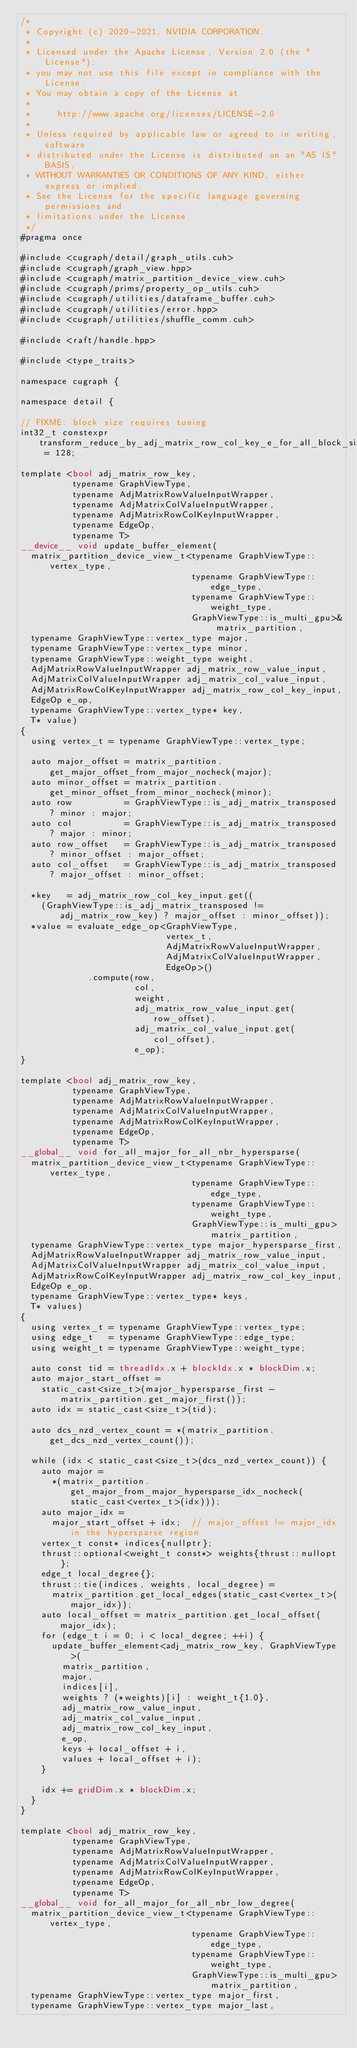Convert code to text. <code><loc_0><loc_0><loc_500><loc_500><_Cuda_>/*
 * Copyright (c) 2020-2021, NVIDIA CORPORATION.
 *
 * Licensed under the Apache License, Version 2.0 (the "License");
 * you may not use this file except in compliance with the License.
 * You may obtain a copy of the License at
 *
 *     http://www.apache.org/licenses/LICENSE-2.0
 *
 * Unless required by applicable law or agreed to in writing, software
 * distributed under the License is distributed on an "AS IS" BASIS,
 * WITHOUT WARRANTIES OR CONDITIONS OF ANY KIND, either express or implied.
 * See the License for the specific language governing permissions and
 * limitations under the License.
 */
#pragma once

#include <cugraph/detail/graph_utils.cuh>
#include <cugraph/graph_view.hpp>
#include <cugraph/matrix_partition_device_view.cuh>
#include <cugraph/prims/property_op_utils.cuh>
#include <cugraph/utilities/dataframe_buffer.cuh>
#include <cugraph/utilities/error.hpp>
#include <cugraph/utilities/shuffle_comm.cuh>

#include <raft/handle.hpp>

#include <type_traits>

namespace cugraph {

namespace detail {

// FIXME: block size requires tuning
int32_t constexpr transform_reduce_by_adj_matrix_row_col_key_e_for_all_block_size = 128;

template <bool adj_matrix_row_key,
          typename GraphViewType,
          typename AdjMatrixRowValueInputWrapper,
          typename AdjMatrixColValueInputWrapper,
          typename AdjMatrixRowColKeyInputWrapper,
          typename EdgeOp,
          typename T>
__device__ void update_buffer_element(
  matrix_partition_device_view_t<typename GraphViewType::vertex_type,
                                 typename GraphViewType::edge_type,
                                 typename GraphViewType::weight_type,
                                 GraphViewType::is_multi_gpu>& matrix_partition,
  typename GraphViewType::vertex_type major,
  typename GraphViewType::vertex_type minor,
  typename GraphViewType::weight_type weight,
  AdjMatrixRowValueInputWrapper adj_matrix_row_value_input,
  AdjMatrixColValueInputWrapper adj_matrix_col_value_input,
  AdjMatrixRowColKeyInputWrapper adj_matrix_row_col_key_input,
  EdgeOp e_op,
  typename GraphViewType::vertex_type* key,
  T* value)
{
  using vertex_t = typename GraphViewType::vertex_type;

  auto major_offset = matrix_partition.get_major_offset_from_major_nocheck(major);
  auto minor_offset = matrix_partition.get_minor_offset_from_minor_nocheck(minor);
  auto row          = GraphViewType::is_adj_matrix_transposed ? minor : major;
  auto col          = GraphViewType::is_adj_matrix_transposed ? major : minor;
  auto row_offset   = GraphViewType::is_adj_matrix_transposed ? minor_offset : major_offset;
  auto col_offset   = GraphViewType::is_adj_matrix_transposed ? major_offset : minor_offset;

  *key   = adj_matrix_row_col_key_input.get((
    (GraphViewType::is_adj_matrix_transposed != adj_matrix_row_key) ? major_offset : minor_offset));
  *value = evaluate_edge_op<GraphViewType,
                            vertex_t,
                            AdjMatrixRowValueInputWrapper,
                            AdjMatrixColValueInputWrapper,
                            EdgeOp>()
             .compute(row,
                      col,
                      weight,
                      adj_matrix_row_value_input.get(row_offset),
                      adj_matrix_col_value_input.get(col_offset),
                      e_op);
}

template <bool adj_matrix_row_key,
          typename GraphViewType,
          typename AdjMatrixRowValueInputWrapper,
          typename AdjMatrixColValueInputWrapper,
          typename AdjMatrixRowColKeyInputWrapper,
          typename EdgeOp,
          typename T>
__global__ void for_all_major_for_all_nbr_hypersparse(
  matrix_partition_device_view_t<typename GraphViewType::vertex_type,
                                 typename GraphViewType::edge_type,
                                 typename GraphViewType::weight_type,
                                 GraphViewType::is_multi_gpu> matrix_partition,
  typename GraphViewType::vertex_type major_hypersparse_first,
  AdjMatrixRowValueInputWrapper adj_matrix_row_value_input,
  AdjMatrixColValueInputWrapper adj_matrix_col_value_input,
  AdjMatrixRowColKeyInputWrapper adj_matrix_row_col_key_input,
  EdgeOp e_op,
  typename GraphViewType::vertex_type* keys,
  T* values)
{
  using vertex_t = typename GraphViewType::vertex_type;
  using edge_t   = typename GraphViewType::edge_type;
  using weight_t = typename GraphViewType::weight_type;

  auto const tid = threadIdx.x + blockIdx.x * blockDim.x;
  auto major_start_offset =
    static_cast<size_t>(major_hypersparse_first - matrix_partition.get_major_first());
  auto idx = static_cast<size_t>(tid);

  auto dcs_nzd_vertex_count = *(matrix_partition.get_dcs_nzd_vertex_count());

  while (idx < static_cast<size_t>(dcs_nzd_vertex_count)) {
    auto major =
      *(matrix_partition.get_major_from_major_hypersparse_idx_nocheck(static_cast<vertex_t>(idx)));
    auto major_idx =
      major_start_offset + idx;  // major_offset != major_idx in the hypersparse region
    vertex_t const* indices{nullptr};
    thrust::optional<weight_t const*> weights{thrust::nullopt};
    edge_t local_degree{};
    thrust::tie(indices, weights, local_degree) =
      matrix_partition.get_local_edges(static_cast<vertex_t>(major_idx));
    auto local_offset = matrix_partition.get_local_offset(major_idx);
    for (edge_t i = 0; i < local_degree; ++i) {
      update_buffer_element<adj_matrix_row_key, GraphViewType>(
        matrix_partition,
        major,
        indices[i],
        weights ? (*weights)[i] : weight_t{1.0},
        adj_matrix_row_value_input,
        adj_matrix_col_value_input,
        adj_matrix_row_col_key_input,
        e_op,
        keys + local_offset + i,
        values + local_offset + i);
    }

    idx += gridDim.x * blockDim.x;
  }
}

template <bool adj_matrix_row_key,
          typename GraphViewType,
          typename AdjMatrixRowValueInputWrapper,
          typename AdjMatrixColValueInputWrapper,
          typename AdjMatrixRowColKeyInputWrapper,
          typename EdgeOp,
          typename T>
__global__ void for_all_major_for_all_nbr_low_degree(
  matrix_partition_device_view_t<typename GraphViewType::vertex_type,
                                 typename GraphViewType::edge_type,
                                 typename GraphViewType::weight_type,
                                 GraphViewType::is_multi_gpu> matrix_partition,
  typename GraphViewType::vertex_type major_first,
  typename GraphViewType::vertex_type major_last,</code> 